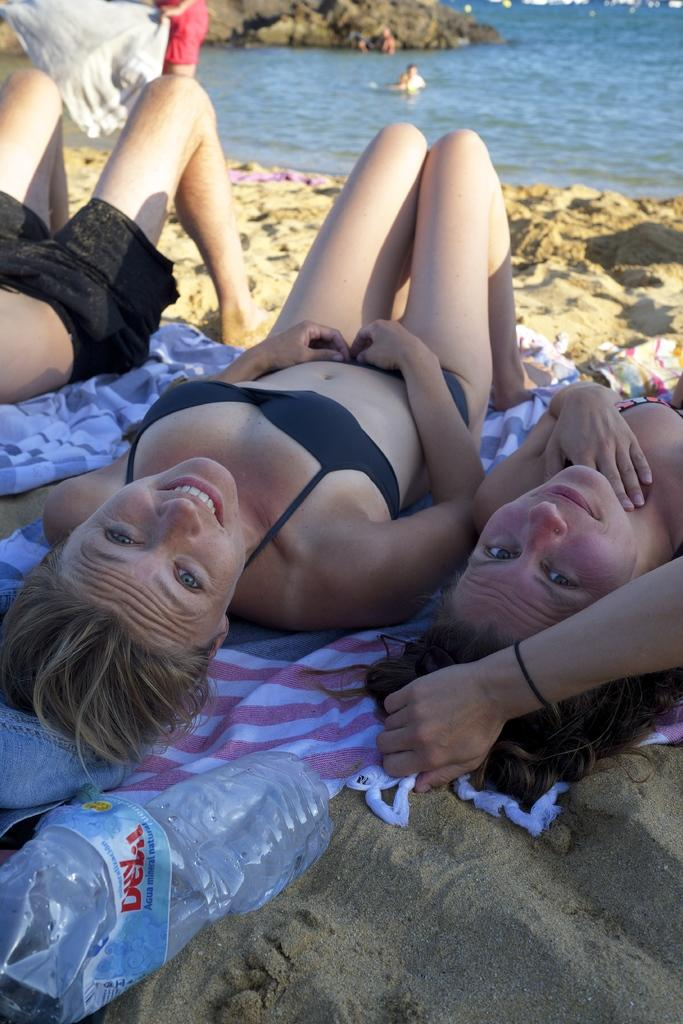Who is present in the image? There are people in the image. What are some of the people doing in the image? Some people are lying on clothes. What can be seen in the background of the image? There are people in the water in the background of the image. What object is visible in the image? There is a bottle visible in the image. How many children are playing with the mouth of the bottle in the image? There is no mention of a bottle with a mouth or children playing with it in the image. 